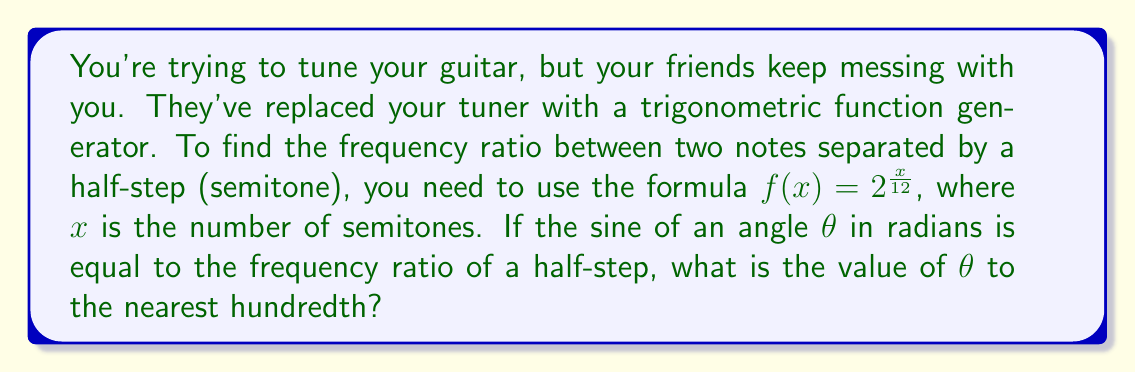Solve this math problem. Let's approach this step-by-step:

1) First, we need to calculate the frequency ratio for a half-step (semitone). Using the given formula:

   $f(x) = 2^{\frac{x}{12}}$

   For a half-step, $x = 1$, so:

   $f(1) = 2^{\frac{1}{12}} \approx 1.0594630943592953$

2) Now, we're told that this frequency ratio is equal to the sine of $\theta$:

   $\sin(\theta) = 2^{\frac{1}{12}}$

3) To find $\theta$, we need to take the inverse sine (arcsin) of both sides:

   $\theta = \arcsin(2^{\frac{1}{12}})$

4) Using a calculator or computer, we can evaluate this:

   $\theta \approx 0.5827642210730984$ radians

5) Converting to degrees (multiply by $\frac{180}{\pi}$):

   $\theta \approx 33.38273016° $

6) Rounding to the nearest hundredth:

   $\theta \approx 33.38°$
Answer: $\theta \approx 0.58$ radians or $33.38°$ 